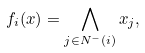<formula> <loc_0><loc_0><loc_500><loc_500>f _ { i } ( x ) = \bigwedge _ { j \in N ^ { - } ( i ) } x _ { j } ,</formula> 